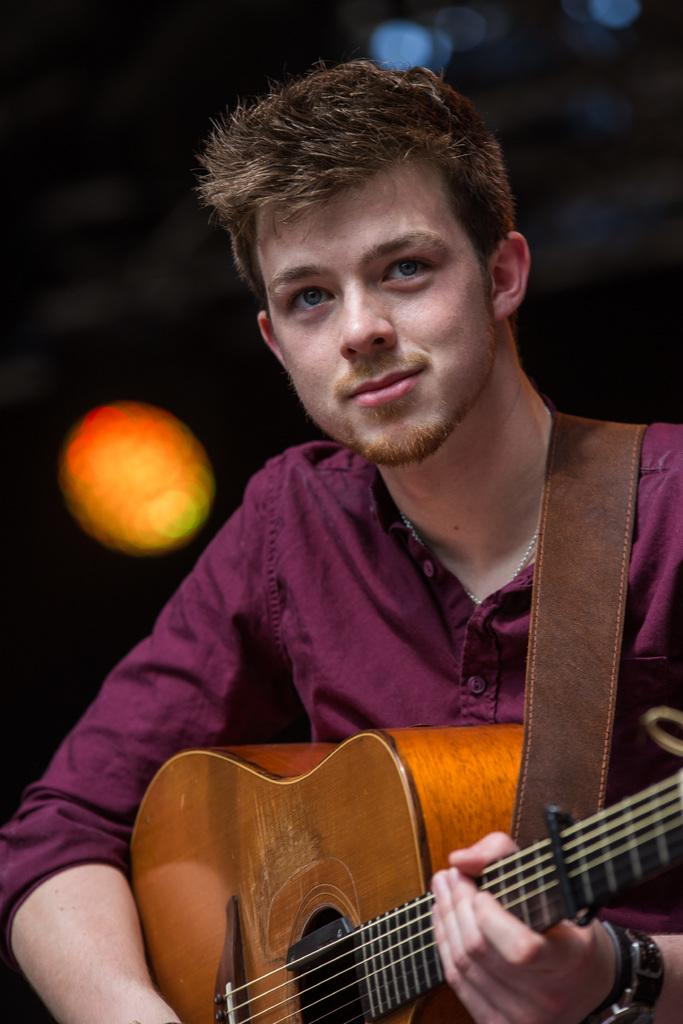Who is the main subject in the picture? There is a boy in the picture. What is the boy doing in the image? The boy is sitting in the image. What is the boy holding in his hands? The boy is holding a guitar in his hands. What can be seen behind the boy in the image? There are spotlights behind the boy. What is the color of the boy's hair? The boy's hair color is brown. What type of cap is the boy wearing in the image? There is no cap visible in the image; the boy's hair color is brown. 